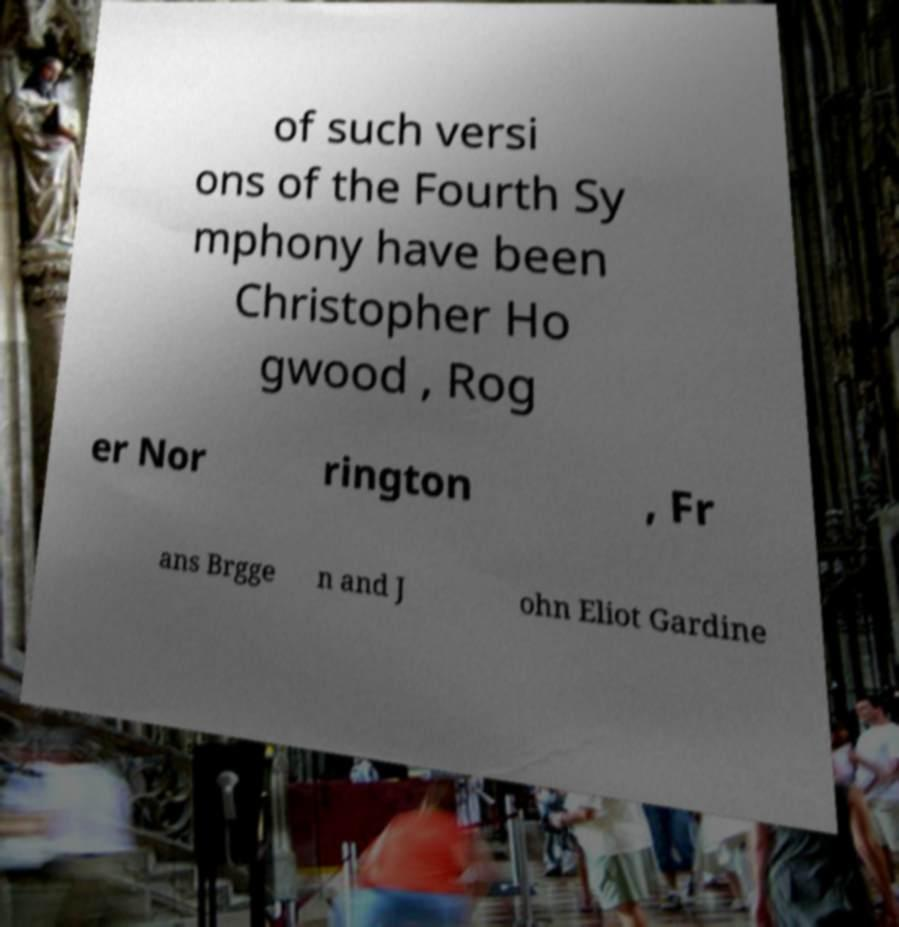I need the written content from this picture converted into text. Can you do that? of such versi ons of the Fourth Sy mphony have been Christopher Ho gwood , Rog er Nor rington , Fr ans Brgge n and J ohn Eliot Gardine 